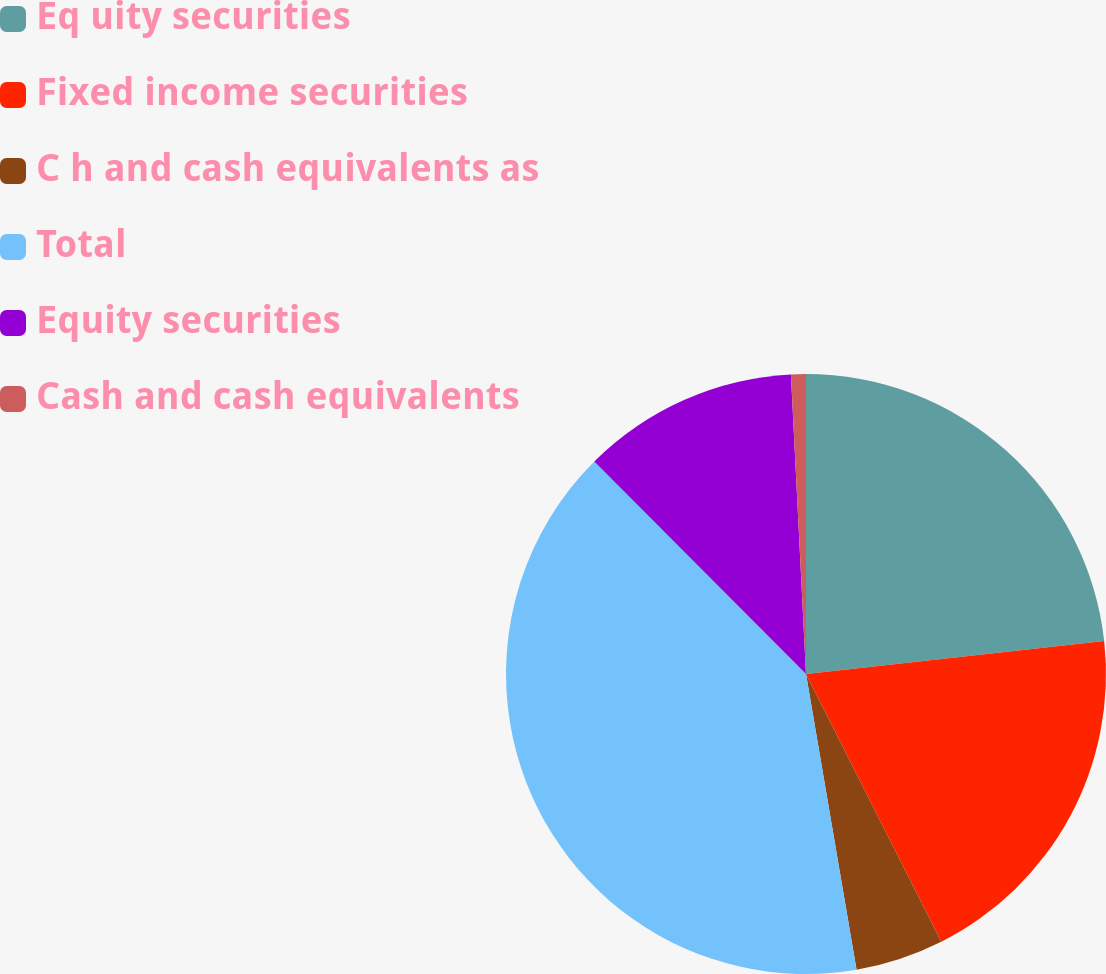Convert chart to OTSL. <chart><loc_0><loc_0><loc_500><loc_500><pie_chart><fcel>Eq uity securities<fcel>Fixed income securities<fcel>C h and cash equivalents as<fcel>Total<fcel>Equity securities<fcel>Cash and cash equivalents<nl><fcel>23.25%<fcel>19.31%<fcel>4.75%<fcel>40.23%<fcel>11.67%<fcel>0.8%<nl></chart> 